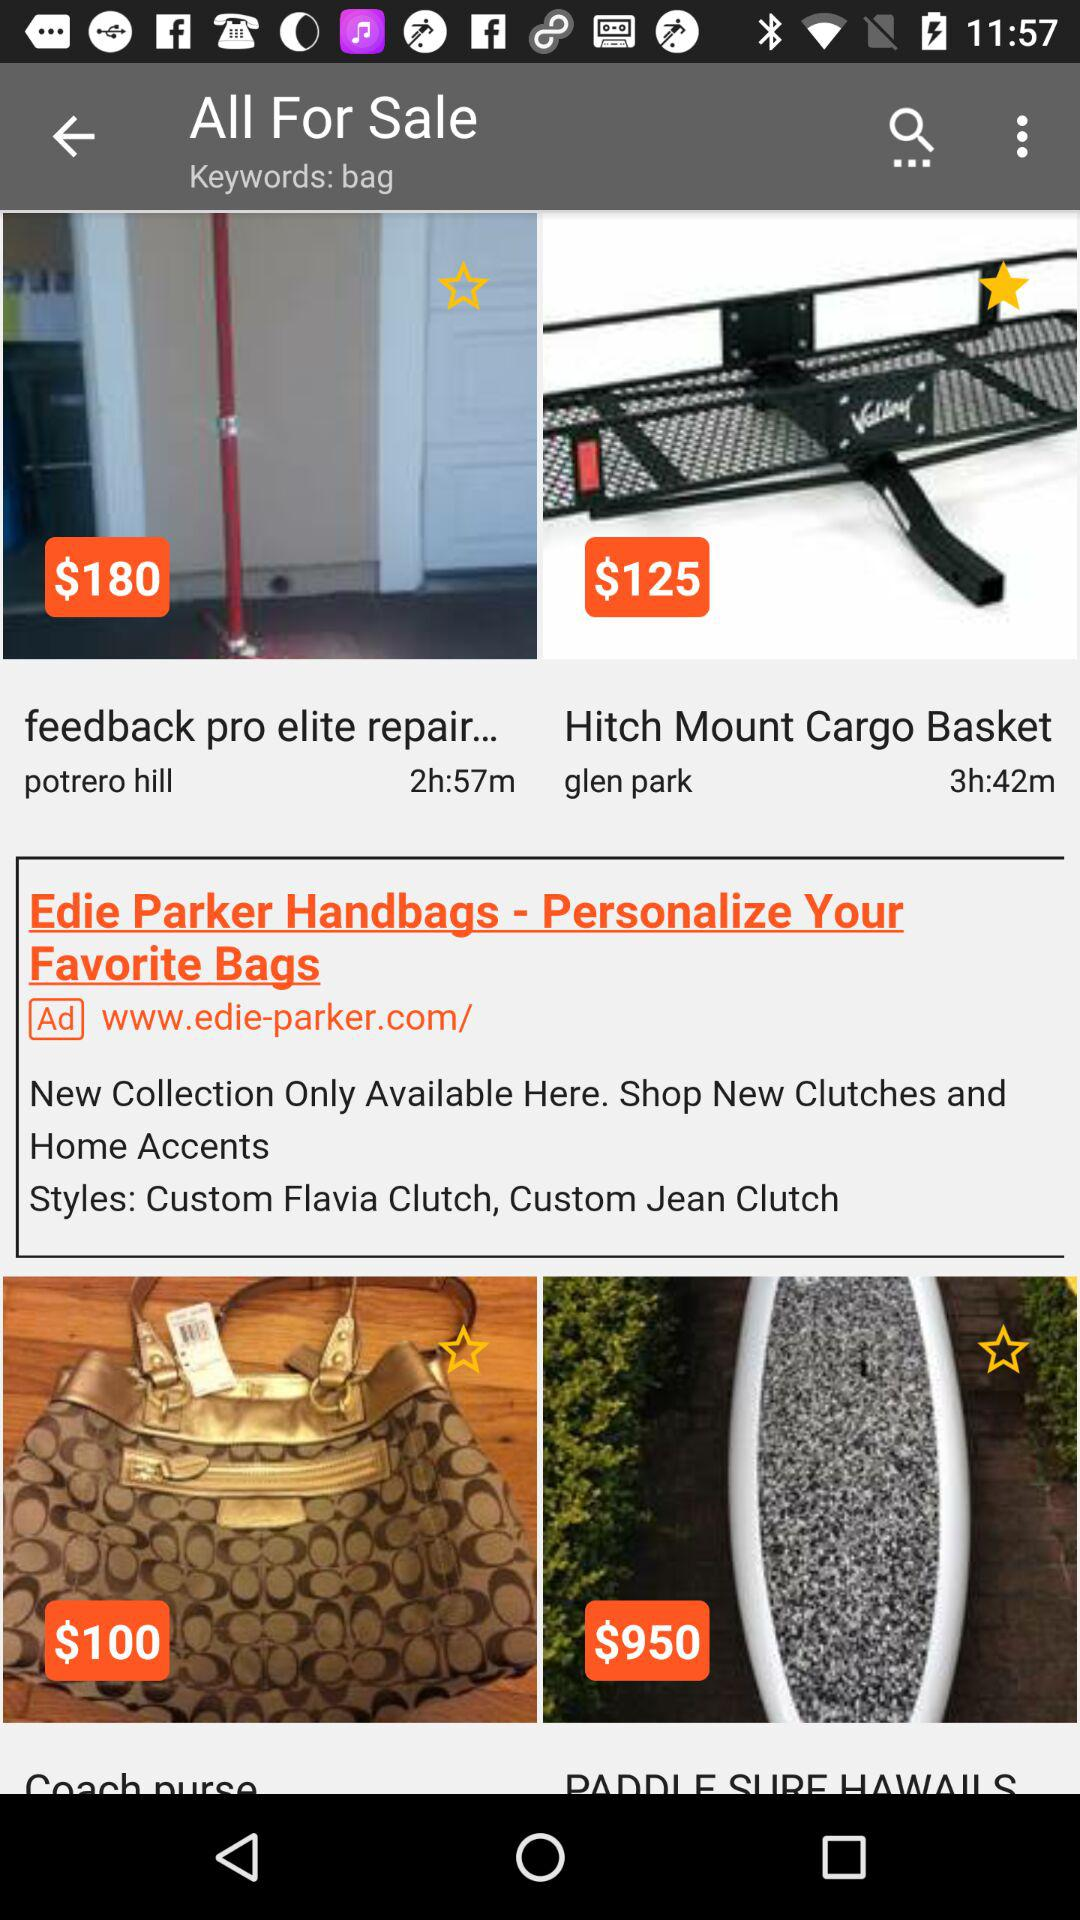When will the sale of elite repair end? The sale will be over in 2 hours and 57 minutes. 